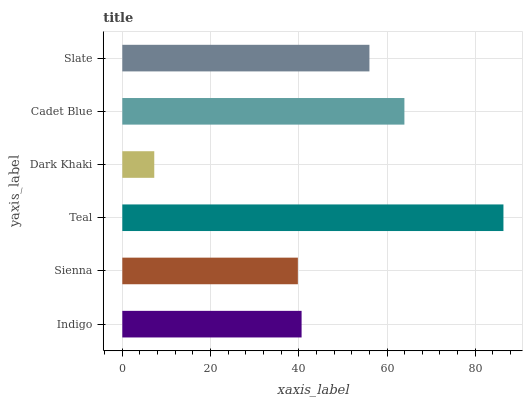Is Dark Khaki the minimum?
Answer yes or no. Yes. Is Teal the maximum?
Answer yes or no. Yes. Is Sienna the minimum?
Answer yes or no. No. Is Sienna the maximum?
Answer yes or no. No. Is Indigo greater than Sienna?
Answer yes or no. Yes. Is Sienna less than Indigo?
Answer yes or no. Yes. Is Sienna greater than Indigo?
Answer yes or no. No. Is Indigo less than Sienna?
Answer yes or no. No. Is Slate the high median?
Answer yes or no. Yes. Is Indigo the low median?
Answer yes or no. Yes. Is Dark Khaki the high median?
Answer yes or no. No. Is Dark Khaki the low median?
Answer yes or no. No. 